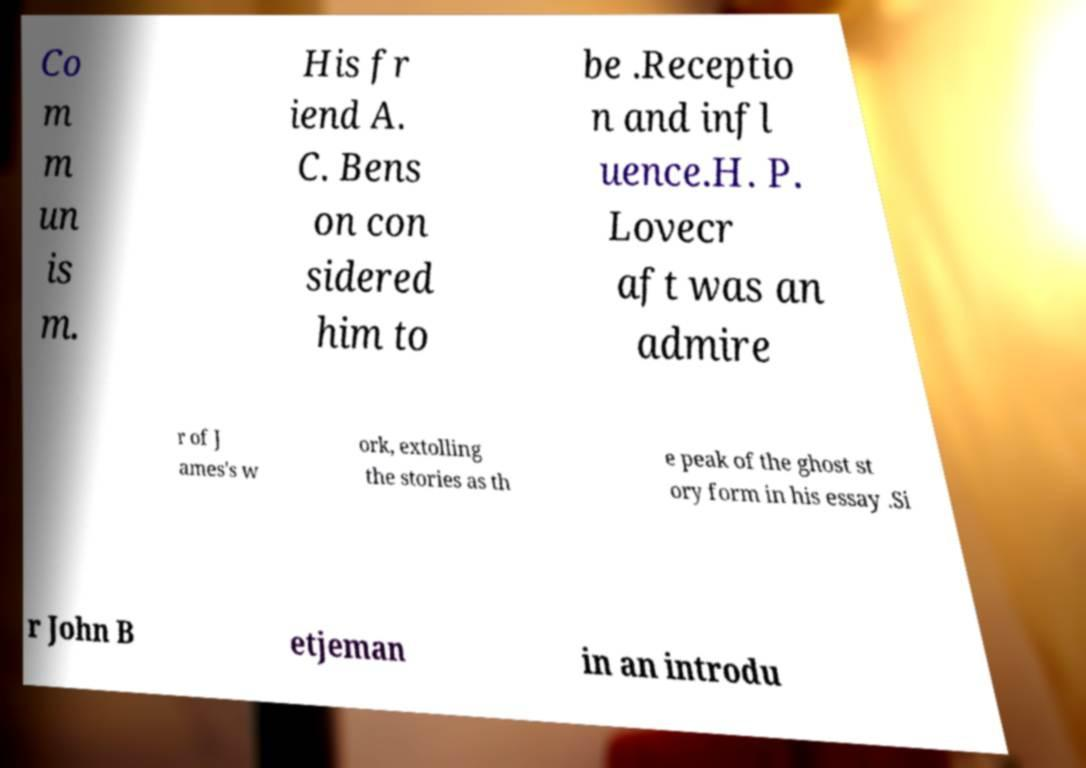I need the written content from this picture converted into text. Can you do that? Co m m un is m. His fr iend A. C. Bens on con sidered him to be .Receptio n and infl uence.H. P. Lovecr aft was an admire r of J ames's w ork, extolling the stories as th e peak of the ghost st ory form in his essay .Si r John B etjeman in an introdu 